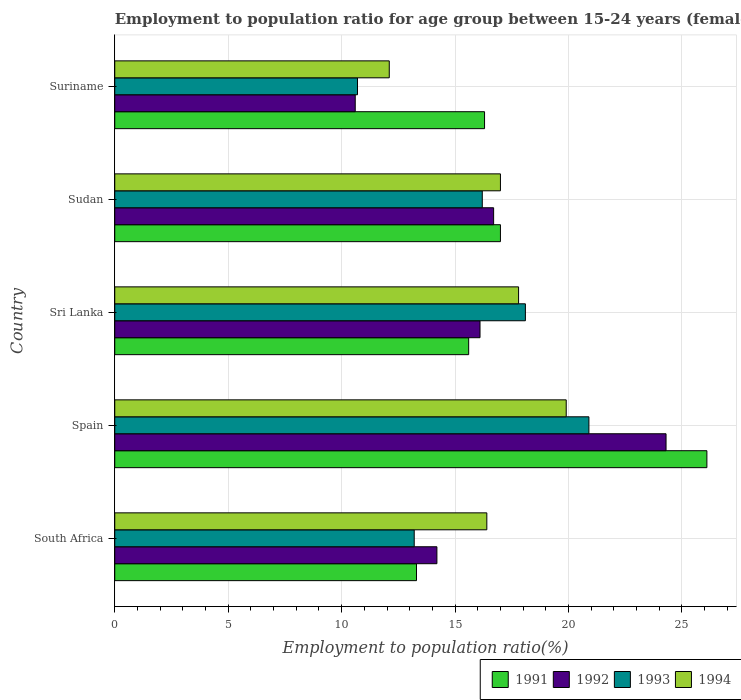How many different coloured bars are there?
Ensure brevity in your answer.  4. Are the number of bars per tick equal to the number of legend labels?
Provide a succinct answer. Yes. Are the number of bars on each tick of the Y-axis equal?
Make the answer very short. Yes. How many bars are there on the 3rd tick from the bottom?
Provide a succinct answer. 4. What is the label of the 2nd group of bars from the top?
Give a very brief answer. Sudan. In how many cases, is the number of bars for a given country not equal to the number of legend labels?
Make the answer very short. 0. What is the employment to population ratio in 1992 in South Africa?
Make the answer very short. 14.2. Across all countries, what is the maximum employment to population ratio in 1991?
Your response must be concise. 26.1. Across all countries, what is the minimum employment to population ratio in 1993?
Ensure brevity in your answer.  10.7. In which country was the employment to population ratio in 1992 maximum?
Keep it short and to the point. Spain. In which country was the employment to population ratio in 1991 minimum?
Ensure brevity in your answer.  South Africa. What is the total employment to population ratio in 1991 in the graph?
Offer a very short reply. 88.3. What is the difference between the employment to population ratio in 1992 in South Africa and that in Spain?
Your response must be concise. -10.1. What is the difference between the employment to population ratio in 1994 in Sri Lanka and the employment to population ratio in 1991 in South Africa?
Your answer should be compact. 4.5. What is the average employment to population ratio in 1991 per country?
Make the answer very short. 17.66. What is the difference between the employment to population ratio in 1991 and employment to population ratio in 1993 in South Africa?
Offer a terse response. 0.1. In how many countries, is the employment to population ratio in 1991 greater than 16 %?
Offer a terse response. 3. What is the ratio of the employment to population ratio in 1993 in South Africa to that in Sri Lanka?
Provide a short and direct response. 0.73. Is the difference between the employment to population ratio in 1991 in South Africa and Suriname greater than the difference between the employment to population ratio in 1993 in South Africa and Suriname?
Keep it short and to the point. No. What is the difference between the highest and the second highest employment to population ratio in 1993?
Offer a terse response. 2.8. What is the difference between the highest and the lowest employment to population ratio in 1993?
Ensure brevity in your answer.  10.2. Is it the case that in every country, the sum of the employment to population ratio in 1991 and employment to population ratio in 1994 is greater than the sum of employment to population ratio in 1992 and employment to population ratio in 1993?
Provide a short and direct response. Yes. Is it the case that in every country, the sum of the employment to population ratio in 1991 and employment to population ratio in 1993 is greater than the employment to population ratio in 1992?
Give a very brief answer. Yes. How many bars are there?
Your answer should be compact. 20. How many countries are there in the graph?
Make the answer very short. 5. Are the values on the major ticks of X-axis written in scientific E-notation?
Your answer should be very brief. No. Where does the legend appear in the graph?
Provide a short and direct response. Bottom right. What is the title of the graph?
Provide a short and direct response. Employment to population ratio for age group between 15-24 years (females). Does "1987" appear as one of the legend labels in the graph?
Offer a very short reply. No. What is the label or title of the X-axis?
Your answer should be compact. Employment to population ratio(%). What is the Employment to population ratio(%) in 1991 in South Africa?
Keep it short and to the point. 13.3. What is the Employment to population ratio(%) of 1992 in South Africa?
Keep it short and to the point. 14.2. What is the Employment to population ratio(%) of 1993 in South Africa?
Make the answer very short. 13.2. What is the Employment to population ratio(%) in 1994 in South Africa?
Provide a short and direct response. 16.4. What is the Employment to population ratio(%) of 1991 in Spain?
Provide a short and direct response. 26.1. What is the Employment to population ratio(%) of 1992 in Spain?
Ensure brevity in your answer.  24.3. What is the Employment to population ratio(%) of 1993 in Spain?
Provide a succinct answer. 20.9. What is the Employment to population ratio(%) in 1994 in Spain?
Keep it short and to the point. 19.9. What is the Employment to population ratio(%) of 1991 in Sri Lanka?
Your response must be concise. 15.6. What is the Employment to population ratio(%) of 1992 in Sri Lanka?
Make the answer very short. 16.1. What is the Employment to population ratio(%) in 1993 in Sri Lanka?
Provide a succinct answer. 18.1. What is the Employment to population ratio(%) in 1994 in Sri Lanka?
Provide a succinct answer. 17.8. What is the Employment to population ratio(%) in 1991 in Sudan?
Provide a succinct answer. 17. What is the Employment to population ratio(%) in 1992 in Sudan?
Keep it short and to the point. 16.7. What is the Employment to population ratio(%) in 1993 in Sudan?
Your answer should be compact. 16.2. What is the Employment to population ratio(%) of 1994 in Sudan?
Offer a very short reply. 17. What is the Employment to population ratio(%) of 1991 in Suriname?
Make the answer very short. 16.3. What is the Employment to population ratio(%) of 1992 in Suriname?
Provide a succinct answer. 10.6. What is the Employment to population ratio(%) of 1993 in Suriname?
Ensure brevity in your answer.  10.7. What is the Employment to population ratio(%) in 1994 in Suriname?
Offer a very short reply. 12.1. Across all countries, what is the maximum Employment to population ratio(%) in 1991?
Offer a very short reply. 26.1. Across all countries, what is the maximum Employment to population ratio(%) in 1992?
Your response must be concise. 24.3. Across all countries, what is the maximum Employment to population ratio(%) in 1993?
Ensure brevity in your answer.  20.9. Across all countries, what is the maximum Employment to population ratio(%) of 1994?
Your answer should be very brief. 19.9. Across all countries, what is the minimum Employment to population ratio(%) in 1991?
Offer a very short reply. 13.3. Across all countries, what is the minimum Employment to population ratio(%) of 1992?
Provide a succinct answer. 10.6. Across all countries, what is the minimum Employment to population ratio(%) of 1993?
Offer a terse response. 10.7. Across all countries, what is the minimum Employment to population ratio(%) in 1994?
Give a very brief answer. 12.1. What is the total Employment to population ratio(%) in 1991 in the graph?
Keep it short and to the point. 88.3. What is the total Employment to population ratio(%) of 1992 in the graph?
Provide a succinct answer. 81.9. What is the total Employment to population ratio(%) of 1993 in the graph?
Provide a succinct answer. 79.1. What is the total Employment to population ratio(%) in 1994 in the graph?
Give a very brief answer. 83.2. What is the difference between the Employment to population ratio(%) in 1992 in South Africa and that in Spain?
Your answer should be very brief. -10.1. What is the difference between the Employment to population ratio(%) in 1994 in South Africa and that in Spain?
Give a very brief answer. -3.5. What is the difference between the Employment to population ratio(%) in 1991 in South Africa and that in Sri Lanka?
Offer a terse response. -2.3. What is the difference between the Employment to population ratio(%) of 1992 in South Africa and that in Sri Lanka?
Make the answer very short. -1.9. What is the difference between the Employment to population ratio(%) of 1993 in South Africa and that in Sri Lanka?
Make the answer very short. -4.9. What is the difference between the Employment to population ratio(%) of 1993 in South Africa and that in Sudan?
Make the answer very short. -3. What is the difference between the Employment to population ratio(%) in 1994 in South Africa and that in Sudan?
Keep it short and to the point. -0.6. What is the difference between the Employment to population ratio(%) in 1991 in South Africa and that in Suriname?
Provide a short and direct response. -3. What is the difference between the Employment to population ratio(%) in 1993 in South Africa and that in Suriname?
Make the answer very short. 2.5. What is the difference between the Employment to population ratio(%) of 1991 in Spain and that in Sri Lanka?
Offer a very short reply. 10.5. What is the difference between the Employment to population ratio(%) of 1992 in Spain and that in Sri Lanka?
Make the answer very short. 8.2. What is the difference between the Employment to population ratio(%) of 1993 in Spain and that in Sri Lanka?
Make the answer very short. 2.8. What is the difference between the Employment to population ratio(%) in 1991 in Spain and that in Sudan?
Give a very brief answer. 9.1. What is the difference between the Employment to population ratio(%) of 1993 in Spain and that in Sudan?
Offer a terse response. 4.7. What is the difference between the Employment to population ratio(%) of 1994 in Spain and that in Sudan?
Your answer should be compact. 2.9. What is the difference between the Employment to population ratio(%) of 1992 in Spain and that in Suriname?
Your answer should be compact. 13.7. What is the difference between the Employment to population ratio(%) of 1993 in Spain and that in Suriname?
Your response must be concise. 10.2. What is the difference between the Employment to population ratio(%) in 1994 in Spain and that in Suriname?
Offer a very short reply. 7.8. What is the difference between the Employment to population ratio(%) of 1991 in Sri Lanka and that in Sudan?
Give a very brief answer. -1.4. What is the difference between the Employment to population ratio(%) of 1994 in Sri Lanka and that in Sudan?
Your response must be concise. 0.8. What is the difference between the Employment to population ratio(%) of 1991 in Sri Lanka and that in Suriname?
Offer a very short reply. -0.7. What is the difference between the Employment to population ratio(%) of 1994 in Sri Lanka and that in Suriname?
Keep it short and to the point. 5.7. What is the difference between the Employment to population ratio(%) in 1994 in Sudan and that in Suriname?
Give a very brief answer. 4.9. What is the difference between the Employment to population ratio(%) of 1992 in South Africa and the Employment to population ratio(%) of 1994 in Spain?
Offer a terse response. -5.7. What is the difference between the Employment to population ratio(%) of 1993 in South Africa and the Employment to population ratio(%) of 1994 in Spain?
Your answer should be very brief. -6.7. What is the difference between the Employment to population ratio(%) in 1991 in South Africa and the Employment to population ratio(%) in 1993 in Sri Lanka?
Your response must be concise. -4.8. What is the difference between the Employment to population ratio(%) of 1991 in South Africa and the Employment to population ratio(%) of 1994 in Sri Lanka?
Provide a short and direct response. -4.5. What is the difference between the Employment to population ratio(%) in 1992 in South Africa and the Employment to population ratio(%) in 1994 in Sri Lanka?
Your answer should be compact. -3.6. What is the difference between the Employment to population ratio(%) of 1991 in South Africa and the Employment to population ratio(%) of 1993 in Sudan?
Provide a short and direct response. -2.9. What is the difference between the Employment to population ratio(%) of 1991 in South Africa and the Employment to population ratio(%) of 1994 in Sudan?
Your answer should be compact. -3.7. What is the difference between the Employment to population ratio(%) of 1991 in South Africa and the Employment to population ratio(%) of 1992 in Suriname?
Offer a terse response. 2.7. What is the difference between the Employment to population ratio(%) in 1991 in South Africa and the Employment to population ratio(%) in 1993 in Suriname?
Offer a very short reply. 2.6. What is the difference between the Employment to population ratio(%) of 1991 in South Africa and the Employment to population ratio(%) of 1994 in Suriname?
Keep it short and to the point. 1.2. What is the difference between the Employment to population ratio(%) in 1992 in South Africa and the Employment to population ratio(%) in 1993 in Suriname?
Keep it short and to the point. 3.5. What is the difference between the Employment to population ratio(%) in 1993 in South Africa and the Employment to population ratio(%) in 1994 in Suriname?
Offer a very short reply. 1.1. What is the difference between the Employment to population ratio(%) of 1991 in Spain and the Employment to population ratio(%) of 1992 in Sri Lanka?
Make the answer very short. 10. What is the difference between the Employment to population ratio(%) in 1991 in Spain and the Employment to population ratio(%) in 1994 in Sri Lanka?
Your answer should be compact. 8.3. What is the difference between the Employment to population ratio(%) in 1993 in Spain and the Employment to population ratio(%) in 1994 in Sri Lanka?
Give a very brief answer. 3.1. What is the difference between the Employment to population ratio(%) in 1991 in Spain and the Employment to population ratio(%) in 1994 in Sudan?
Provide a short and direct response. 9.1. What is the difference between the Employment to population ratio(%) in 1991 in Spain and the Employment to population ratio(%) in 1992 in Suriname?
Provide a succinct answer. 15.5. What is the difference between the Employment to population ratio(%) of 1991 in Spain and the Employment to population ratio(%) of 1993 in Suriname?
Keep it short and to the point. 15.4. What is the difference between the Employment to population ratio(%) in 1992 in Sri Lanka and the Employment to population ratio(%) in 1994 in Sudan?
Your answer should be compact. -0.9. What is the difference between the Employment to population ratio(%) of 1991 in Sudan and the Employment to population ratio(%) of 1992 in Suriname?
Offer a very short reply. 6.4. What is the difference between the Employment to population ratio(%) in 1991 in Sudan and the Employment to population ratio(%) in 1994 in Suriname?
Your response must be concise. 4.9. What is the difference between the Employment to population ratio(%) of 1992 in Sudan and the Employment to population ratio(%) of 1993 in Suriname?
Ensure brevity in your answer.  6. What is the difference between the Employment to population ratio(%) of 1993 in Sudan and the Employment to population ratio(%) of 1994 in Suriname?
Your answer should be very brief. 4.1. What is the average Employment to population ratio(%) in 1991 per country?
Give a very brief answer. 17.66. What is the average Employment to population ratio(%) of 1992 per country?
Provide a short and direct response. 16.38. What is the average Employment to population ratio(%) in 1993 per country?
Make the answer very short. 15.82. What is the average Employment to population ratio(%) in 1994 per country?
Provide a succinct answer. 16.64. What is the difference between the Employment to population ratio(%) of 1992 and Employment to population ratio(%) of 1993 in South Africa?
Give a very brief answer. 1. What is the difference between the Employment to population ratio(%) of 1993 and Employment to population ratio(%) of 1994 in South Africa?
Ensure brevity in your answer.  -3.2. What is the difference between the Employment to population ratio(%) in 1991 and Employment to population ratio(%) in 1993 in Spain?
Keep it short and to the point. 5.2. What is the difference between the Employment to population ratio(%) of 1991 and Employment to population ratio(%) of 1994 in Spain?
Provide a succinct answer. 6.2. What is the difference between the Employment to population ratio(%) of 1993 and Employment to population ratio(%) of 1994 in Spain?
Offer a terse response. 1. What is the difference between the Employment to population ratio(%) of 1991 and Employment to population ratio(%) of 1992 in Sri Lanka?
Your answer should be very brief. -0.5. What is the difference between the Employment to population ratio(%) of 1991 and Employment to population ratio(%) of 1994 in Sri Lanka?
Offer a very short reply. -2.2. What is the difference between the Employment to population ratio(%) of 1992 and Employment to population ratio(%) of 1994 in Sri Lanka?
Your answer should be compact. -1.7. What is the difference between the Employment to population ratio(%) in 1993 and Employment to population ratio(%) in 1994 in Sri Lanka?
Ensure brevity in your answer.  0.3. What is the difference between the Employment to population ratio(%) in 1991 and Employment to population ratio(%) in 1994 in Sudan?
Offer a terse response. 0. What is the difference between the Employment to population ratio(%) in 1992 and Employment to population ratio(%) in 1994 in Sudan?
Your response must be concise. -0.3. What is the difference between the Employment to population ratio(%) in 1991 and Employment to population ratio(%) in 1992 in Suriname?
Make the answer very short. 5.7. What is the difference between the Employment to population ratio(%) of 1991 and Employment to population ratio(%) of 1993 in Suriname?
Give a very brief answer. 5.6. What is the difference between the Employment to population ratio(%) in 1992 and Employment to population ratio(%) in 1993 in Suriname?
Provide a short and direct response. -0.1. What is the difference between the Employment to population ratio(%) of 1992 and Employment to population ratio(%) of 1994 in Suriname?
Offer a terse response. -1.5. What is the ratio of the Employment to population ratio(%) of 1991 in South Africa to that in Spain?
Make the answer very short. 0.51. What is the ratio of the Employment to population ratio(%) of 1992 in South Africa to that in Spain?
Offer a terse response. 0.58. What is the ratio of the Employment to population ratio(%) of 1993 in South Africa to that in Spain?
Give a very brief answer. 0.63. What is the ratio of the Employment to population ratio(%) of 1994 in South Africa to that in Spain?
Make the answer very short. 0.82. What is the ratio of the Employment to population ratio(%) of 1991 in South Africa to that in Sri Lanka?
Offer a very short reply. 0.85. What is the ratio of the Employment to population ratio(%) of 1992 in South Africa to that in Sri Lanka?
Make the answer very short. 0.88. What is the ratio of the Employment to population ratio(%) of 1993 in South Africa to that in Sri Lanka?
Your answer should be very brief. 0.73. What is the ratio of the Employment to population ratio(%) in 1994 in South Africa to that in Sri Lanka?
Your response must be concise. 0.92. What is the ratio of the Employment to population ratio(%) of 1991 in South Africa to that in Sudan?
Provide a short and direct response. 0.78. What is the ratio of the Employment to population ratio(%) of 1992 in South Africa to that in Sudan?
Provide a short and direct response. 0.85. What is the ratio of the Employment to population ratio(%) of 1993 in South Africa to that in Sudan?
Your answer should be compact. 0.81. What is the ratio of the Employment to population ratio(%) of 1994 in South Africa to that in Sudan?
Your answer should be compact. 0.96. What is the ratio of the Employment to population ratio(%) of 1991 in South Africa to that in Suriname?
Provide a short and direct response. 0.82. What is the ratio of the Employment to population ratio(%) of 1992 in South Africa to that in Suriname?
Keep it short and to the point. 1.34. What is the ratio of the Employment to population ratio(%) of 1993 in South Africa to that in Suriname?
Your response must be concise. 1.23. What is the ratio of the Employment to population ratio(%) in 1994 in South Africa to that in Suriname?
Offer a very short reply. 1.36. What is the ratio of the Employment to population ratio(%) in 1991 in Spain to that in Sri Lanka?
Ensure brevity in your answer.  1.67. What is the ratio of the Employment to population ratio(%) of 1992 in Spain to that in Sri Lanka?
Make the answer very short. 1.51. What is the ratio of the Employment to population ratio(%) in 1993 in Spain to that in Sri Lanka?
Your answer should be compact. 1.15. What is the ratio of the Employment to population ratio(%) in 1994 in Spain to that in Sri Lanka?
Offer a very short reply. 1.12. What is the ratio of the Employment to population ratio(%) of 1991 in Spain to that in Sudan?
Give a very brief answer. 1.54. What is the ratio of the Employment to population ratio(%) of 1992 in Spain to that in Sudan?
Your response must be concise. 1.46. What is the ratio of the Employment to population ratio(%) of 1993 in Spain to that in Sudan?
Ensure brevity in your answer.  1.29. What is the ratio of the Employment to population ratio(%) of 1994 in Spain to that in Sudan?
Your answer should be very brief. 1.17. What is the ratio of the Employment to population ratio(%) in 1991 in Spain to that in Suriname?
Offer a very short reply. 1.6. What is the ratio of the Employment to population ratio(%) of 1992 in Spain to that in Suriname?
Give a very brief answer. 2.29. What is the ratio of the Employment to population ratio(%) of 1993 in Spain to that in Suriname?
Give a very brief answer. 1.95. What is the ratio of the Employment to population ratio(%) in 1994 in Spain to that in Suriname?
Your response must be concise. 1.64. What is the ratio of the Employment to population ratio(%) in 1991 in Sri Lanka to that in Sudan?
Your answer should be very brief. 0.92. What is the ratio of the Employment to population ratio(%) in 1992 in Sri Lanka to that in Sudan?
Ensure brevity in your answer.  0.96. What is the ratio of the Employment to population ratio(%) of 1993 in Sri Lanka to that in Sudan?
Keep it short and to the point. 1.12. What is the ratio of the Employment to population ratio(%) of 1994 in Sri Lanka to that in Sudan?
Offer a very short reply. 1.05. What is the ratio of the Employment to population ratio(%) in 1991 in Sri Lanka to that in Suriname?
Ensure brevity in your answer.  0.96. What is the ratio of the Employment to population ratio(%) of 1992 in Sri Lanka to that in Suriname?
Provide a succinct answer. 1.52. What is the ratio of the Employment to population ratio(%) in 1993 in Sri Lanka to that in Suriname?
Keep it short and to the point. 1.69. What is the ratio of the Employment to population ratio(%) in 1994 in Sri Lanka to that in Suriname?
Give a very brief answer. 1.47. What is the ratio of the Employment to population ratio(%) of 1991 in Sudan to that in Suriname?
Make the answer very short. 1.04. What is the ratio of the Employment to population ratio(%) of 1992 in Sudan to that in Suriname?
Offer a terse response. 1.58. What is the ratio of the Employment to population ratio(%) of 1993 in Sudan to that in Suriname?
Provide a short and direct response. 1.51. What is the ratio of the Employment to population ratio(%) of 1994 in Sudan to that in Suriname?
Your response must be concise. 1.41. What is the difference between the highest and the second highest Employment to population ratio(%) of 1992?
Give a very brief answer. 7.6. What is the difference between the highest and the lowest Employment to population ratio(%) in 1991?
Keep it short and to the point. 12.8. 